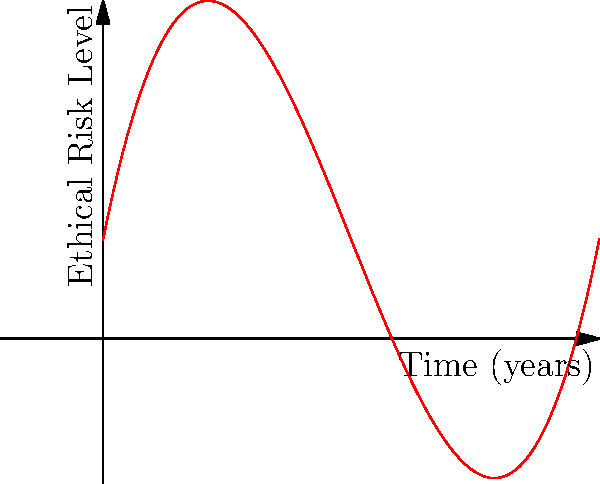The graph above represents a cubic spline function modeling the ethical risks of AI deployment over time. At which point (A, B, or C) does the rate of change in ethical risk level appear to be decreasing most rapidly? To determine where the rate of change in ethical risk level is decreasing most rapidly, we need to analyze the curve's shape and slope:

1. The rate of change is represented by the slope of the curve at any given point.
2. A decreasing rate of change means the slope is becoming less steep (i.e., the curve is flattening out).
3. The point where this is happening most rapidly is where the curve transitions from steep to flat most quickly.

Analyzing the three points:
- Point A: The curve is still relatively steep and increasing.
- Point B: The curve is transitioning from steep to more flat, showing a rapid decrease in slope.
- Point C: The curve has already flattened out significantly, with less rapid change in slope.

Therefore, point B represents the location where the rate of change in ethical risk level appears to be decreasing most rapidly. This is the inflection point of the cubic function, where the curve changes from concave up to concave down.
Answer: B 